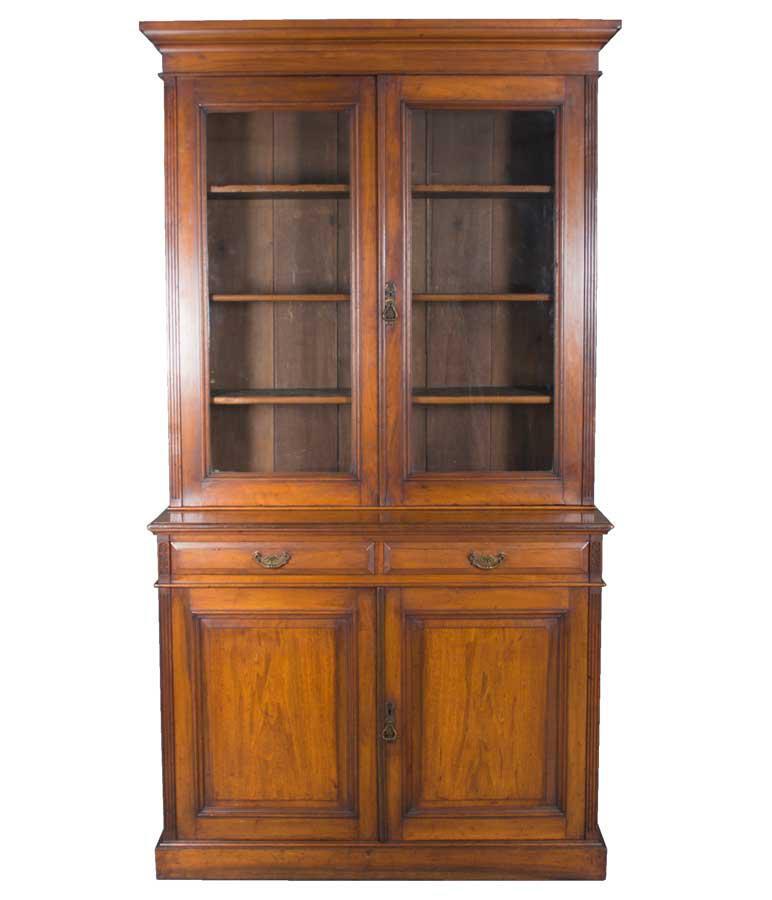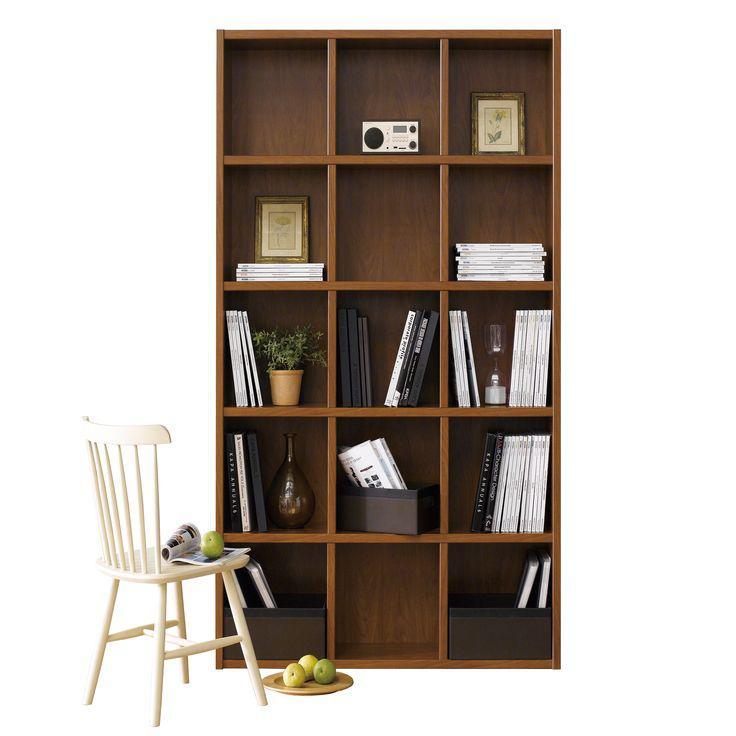The first image is the image on the left, the second image is the image on the right. Considering the images on both sides, is "One brown bookcase has a grid of same-size square compartments, and the other brown bookcase has closed-front storage at the bottom." valid? Answer yes or no. Yes. The first image is the image on the left, the second image is the image on the right. Given the left and right images, does the statement "There are exactly two empty bookcases." hold true? Answer yes or no. No. 